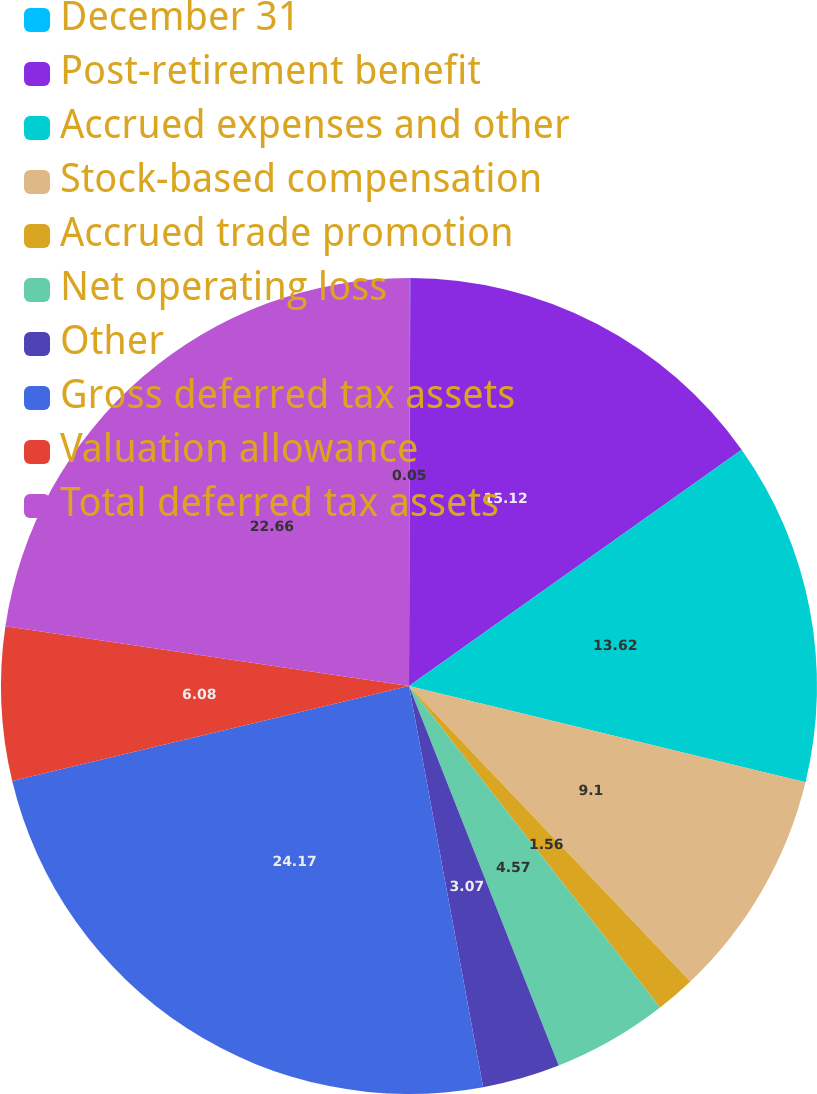<chart> <loc_0><loc_0><loc_500><loc_500><pie_chart><fcel>December 31<fcel>Post-retirement benefit<fcel>Accrued expenses and other<fcel>Stock-based compensation<fcel>Accrued trade promotion<fcel>Net operating loss<fcel>Other<fcel>Gross deferred tax assets<fcel>Valuation allowance<fcel>Total deferred tax assets<nl><fcel>0.05%<fcel>15.12%<fcel>13.62%<fcel>9.1%<fcel>1.56%<fcel>4.57%<fcel>3.07%<fcel>24.17%<fcel>6.08%<fcel>22.66%<nl></chart> 